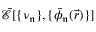<formula> <loc_0><loc_0><loc_500><loc_500>\mathcal { \bar { E } } [ \{ \nu _ { \mathfrak { n } } \} , \{ \bar { \phi } _ { \mathfrak { n } } ( \vec { r } ) \} ]</formula> 